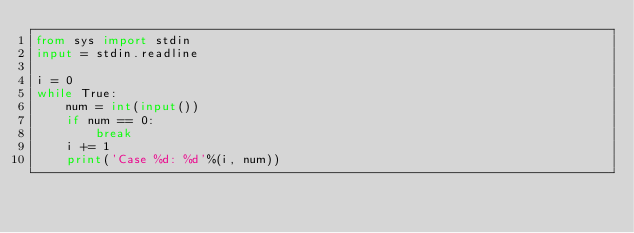<code> <loc_0><loc_0><loc_500><loc_500><_Python_>from sys import stdin
input = stdin.readline

i = 0
while True:
    num = int(input())
    if num == 0:
        break
    i += 1
    print('Case %d: %d'%(i, num))
</code> 